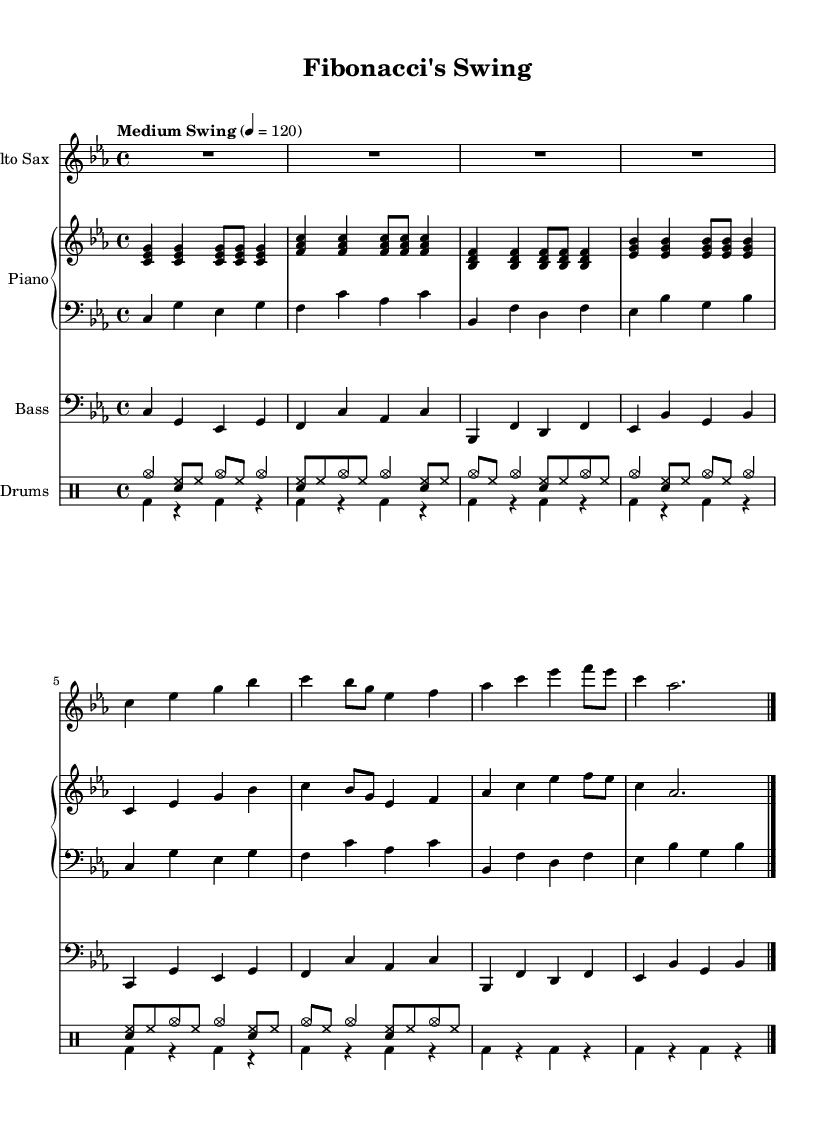What is the key signature of this music? The key signature is C minor, indicated by four flats (B flat, E flat, A flat, and D flat) in the key signature section at the beginning of the staff.
Answer: C minor What is the time signature of the piece? The time signature is 4/4, which indicates that there are four beats in each measure and the quarter note receives one beat. This is usually shown at the beginning of the score.
Answer: 4/4 What is the tempo marking for this piece? The tempo marking is "Medium Swing," indicated at the beginning of the score alongside the metronome marking of 120 beats per minute. This suggests a laid-back yet rhythmic feeling typical of jazz music.
Answer: Medium Swing How many measures are there in the saxophone part? The saxophone part consists of 4 measures, which can be counted by identifying the vertical bar lines that separate the measures.
Answer: 4 What is the dynamic marking for the piano music? There is no explicit dynamic marking shown in the provided code. Typically, jazz pieces may encourage performers to interpret dynamics flexibly, but the absence of markings suggests a standard approach.
Answer: None Which instruments are featured in this score? The score features Alto Saxophone, Piano (with both right-hand and left-hand parts), Bass, and Drums, as indicated by the instrument names at the beginning of each staff.
Answer: Alto Sax, Piano, Bass, Drums What kind of rhythmic pattern do the drums play? The drums exhibit a combination of cymbals and snare with a swing rhythm in the upper voice, while the lower voice includes bass drum hits occurring on a steady pattern. This represents a traditional jazz drumming style.
Answer: Combination of cymbals and bass 